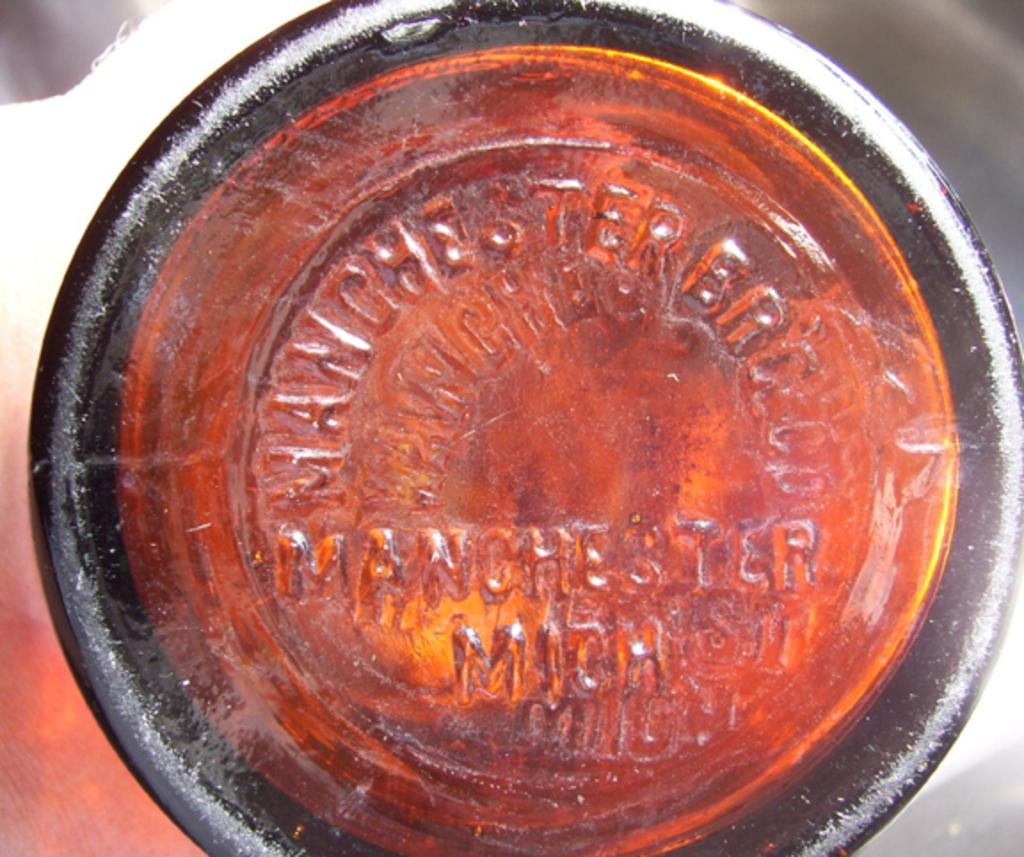What can be seen in the image? There is an object in the image. What is the color of the object? The object is red in color. Are there any words or letters on the object? Yes, the object has text on it. Is the clam holding the object in the image? There is no clam present in the image, so it cannot be holding the object. 